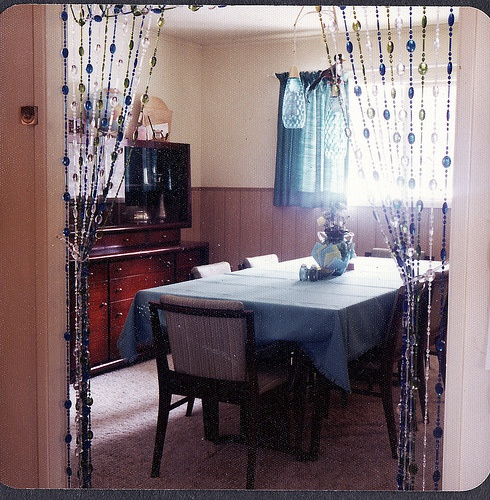Describe the objects in this image and their specific colors. I can see dining table in black, lightgray, navy, and darkgray tones, chair in black, purple, and gray tones, tv in black, lightgray, darkgray, and gray tones, chair in black, navy, gray, and purple tones, and chair in black, purple, and gray tones in this image. 